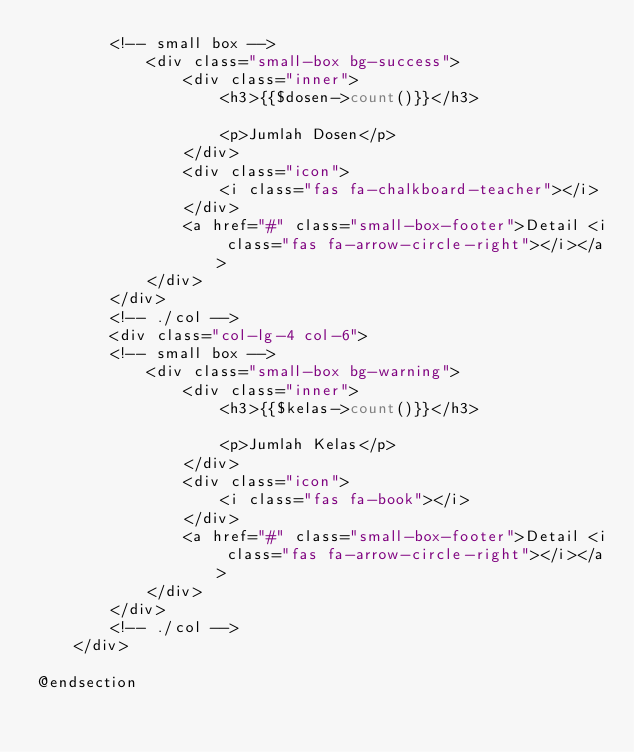<code> <loc_0><loc_0><loc_500><loc_500><_PHP_>        <!-- small box -->
            <div class="small-box bg-success">
                <div class="inner">
                    <h3>{{$dosen->count()}}</h3>

                    <p>Jumlah Dosen</p>
                </div>
                <div class="icon">
                    <i class="fas fa-chalkboard-teacher"></i>
                </div>
                <a href="#" class="small-box-footer">Detail <i class="fas fa-arrow-circle-right"></i></a>
            </div>
        </div>
        <!-- ./col -->
        <div class="col-lg-4 col-6">
        <!-- small box -->
            <div class="small-box bg-warning">
                <div class="inner">
                    <h3>{{$kelas->count()}}</h3>

                    <p>Jumlah Kelas</p>
                </div>
                <div class="icon">
                    <i class="fas fa-book"></i>
                </div>
                <a href="#" class="small-box-footer">Detail <i class="fas fa-arrow-circle-right"></i></a>
            </div>
        </div>
        <!-- ./col -->
    </div>

@endsection</code> 